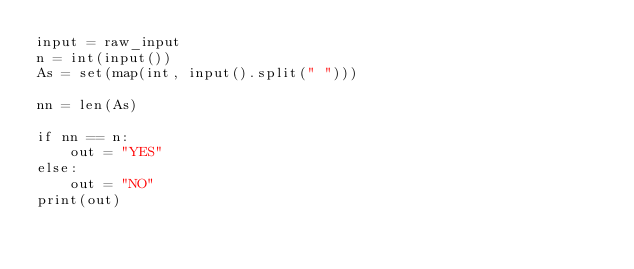<code> <loc_0><loc_0><loc_500><loc_500><_Python_>input = raw_input
n = int(input())
As = set(map(int, input().split(" ")))

nn = len(As)

if nn == n:
    out = "YES"
else:
    out = "NO"
print(out)</code> 